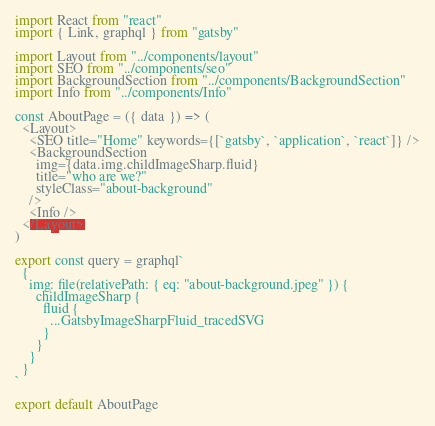Convert code to text. <code><loc_0><loc_0><loc_500><loc_500><_JavaScript_>import React from "react"
import { Link, graphql } from "gatsby"

import Layout from "../components/layout"
import SEO from "../components/seo"
import BackgroundSection from "../components/BackgroundSection"
import Info from "../components/Info"

const AboutPage = ({ data }) => (
  <Layout>
    <SEO title="Home" keywords={[`gatsby`, `application`, `react`]} />
    <BackgroundSection
      img={data.img.childImageSharp.fluid}
      title="who are we?"
      styleClass="about-background"
    />
    <Info />
  </Layout>
)

export const query = graphql`
  {
    img: file(relativePath: { eq: "about-background.jpeg" }) {
      childImageSharp {
        fluid {
          ...GatsbyImageSharpFluid_tracedSVG
        }
      }
    }
  }
`

export default AboutPage
</code> 